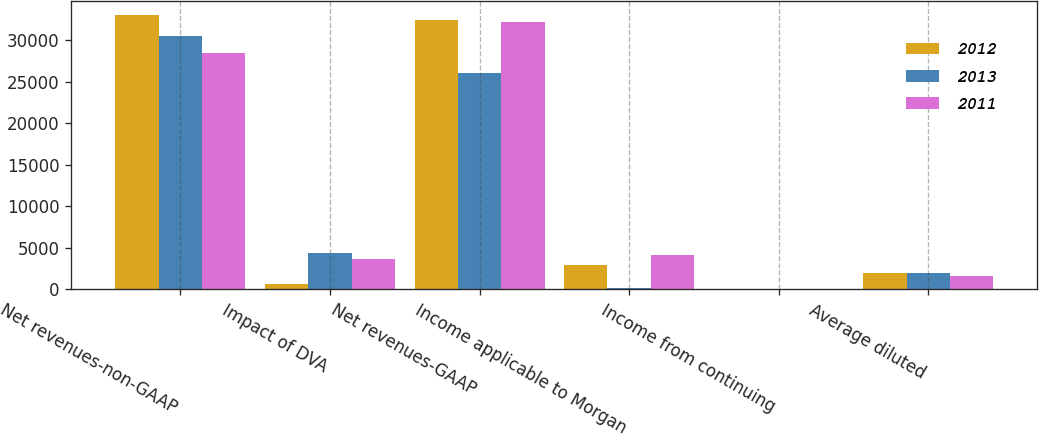Convert chart to OTSL. <chart><loc_0><loc_0><loc_500><loc_500><stacked_bar_chart><ecel><fcel>Net revenues-non-GAAP<fcel>Impact of DVA<fcel>Net revenues-GAAP<fcel>Income applicable to Morgan<fcel>Income from continuing<fcel>Average diluted<nl><fcel>2012<fcel>33098<fcel>681<fcel>32417<fcel>2975<fcel>1.38<fcel>1957<nl><fcel>2013<fcel>30504<fcel>4402<fcel>26102<fcel>138<fcel>0.02<fcel>1919<nl><fcel>2011<fcel>28546<fcel>3681<fcel>32227<fcel>4168<fcel>1.27<fcel>1655<nl></chart> 